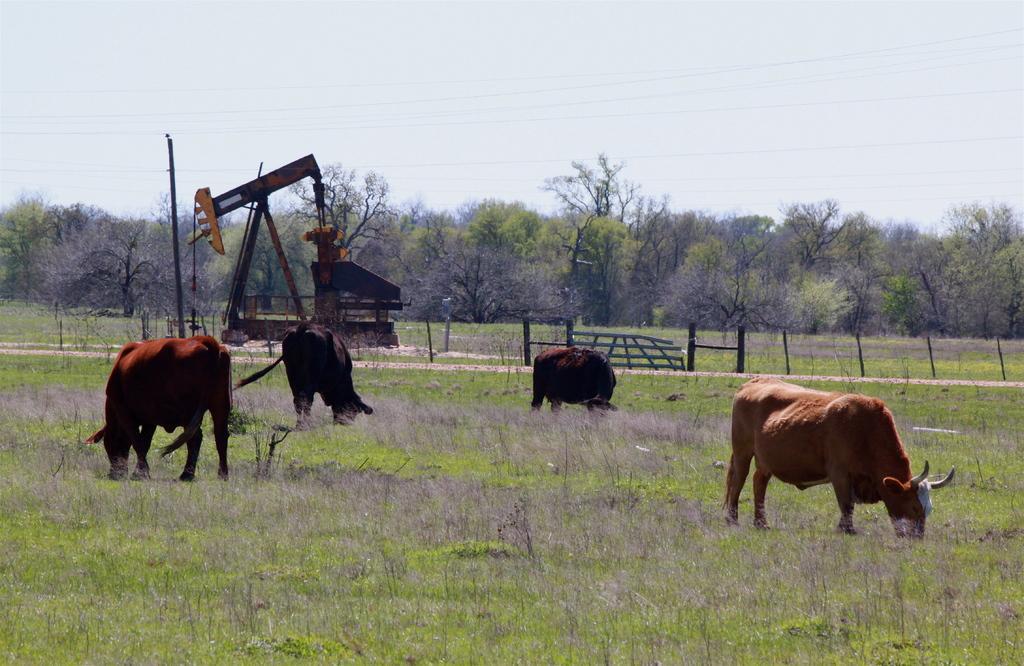Could you give a brief overview of what you see in this image? In this image we can see the animals eating the grass. We can also see the path, fence, crane and also many trees. We can see the electrical pole with the wires. Sky is also visible in this image. 